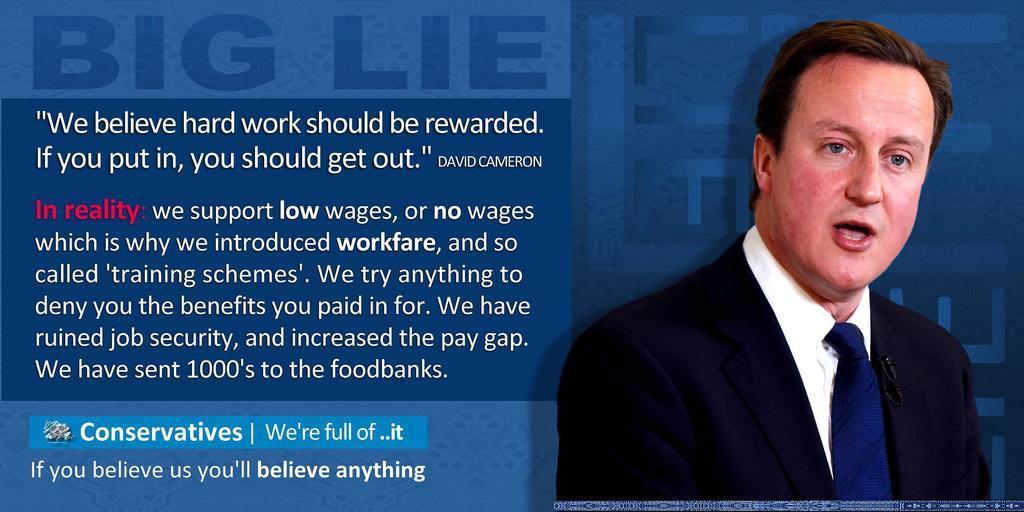In one or two sentences, can you explain what this image depicts? In the picture we can see a news article on it, we can see a man wearing a blazer, tie and shirt and beside him we can see some information regarding him and on the top of it is mentioned as a big lie. 